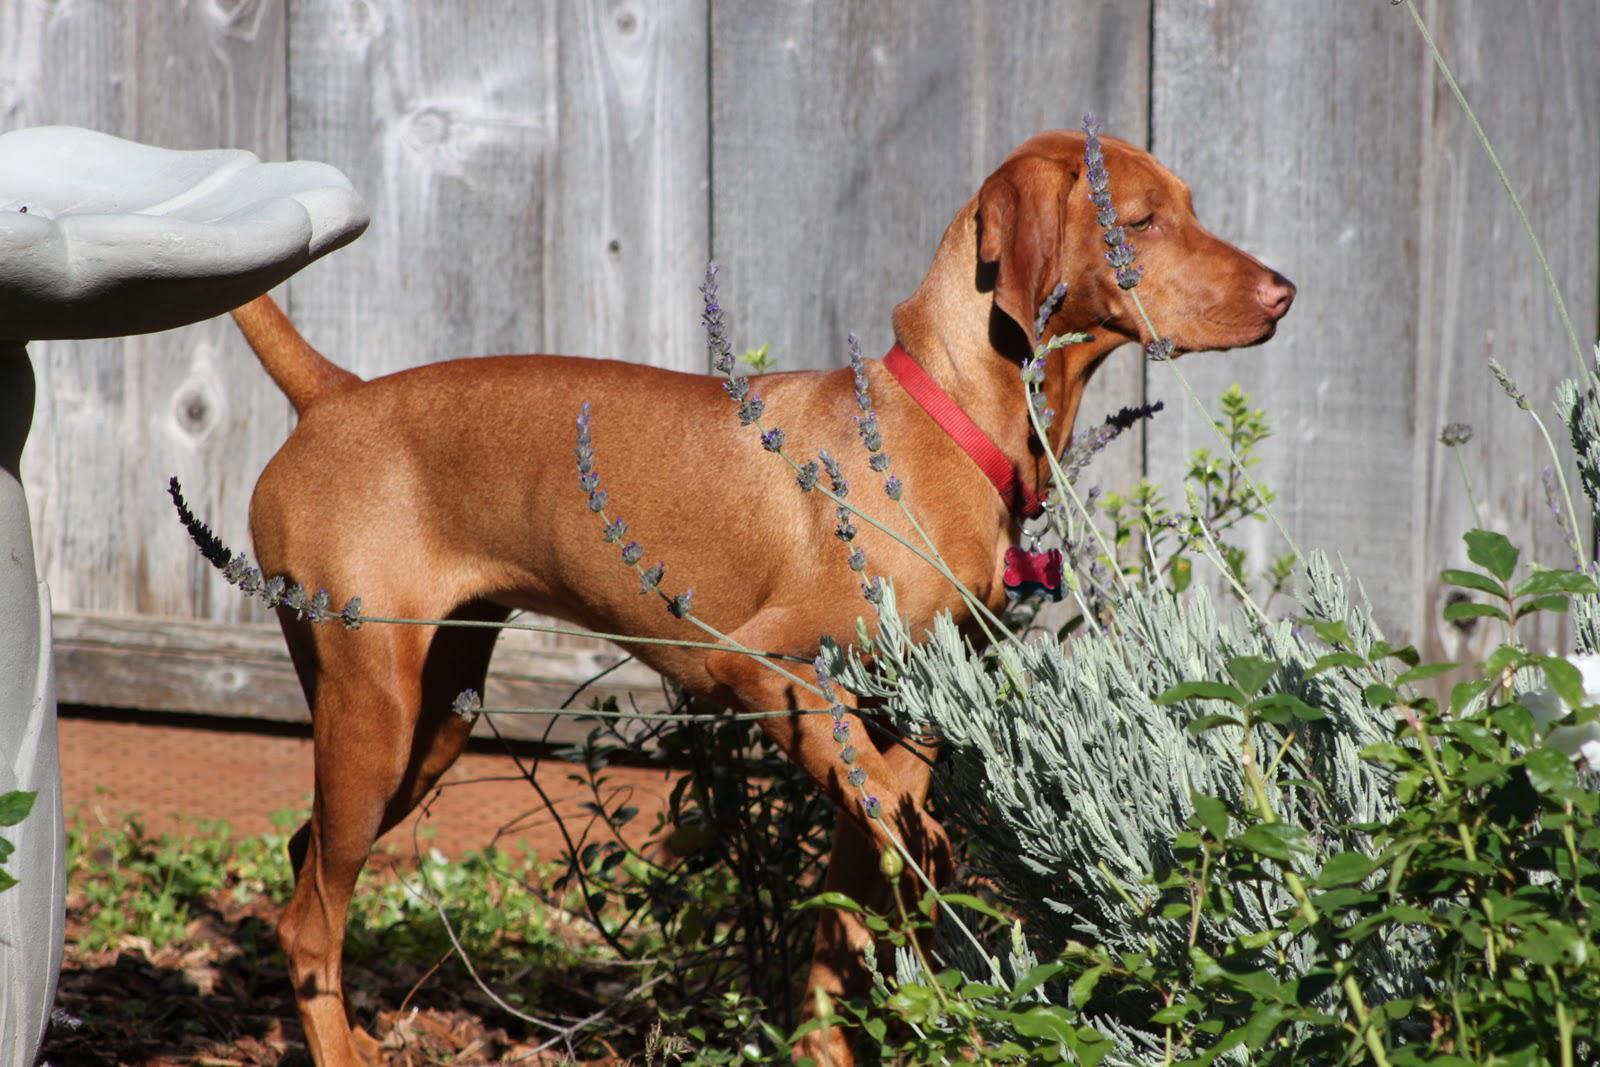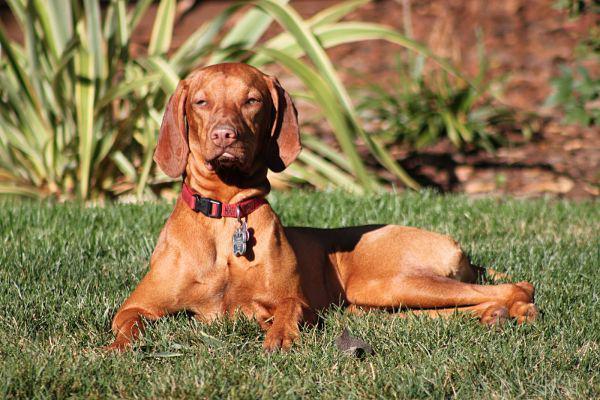The first image is the image on the left, the second image is the image on the right. Examine the images to the left and right. Is the description "There is a dog wearing a red collar in each image." accurate? Answer yes or no. Yes. The first image is the image on the left, the second image is the image on the right. Examine the images to the left and right. Is the description "There is the same number of dogs in both images." accurate? Answer yes or no. Yes. 